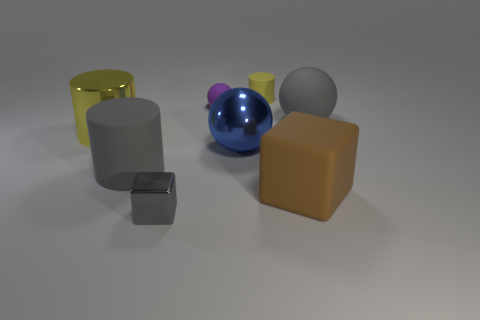What shape is the small object that is the same color as the large shiny cylinder?
Provide a short and direct response. Cylinder. What number of other objects are there of the same size as the blue sphere?
Keep it short and to the point. 4. Does the metallic cylinder have the same color as the small cylinder?
Offer a very short reply. Yes. Are there any other things that have the same color as the tiny metal thing?
Keep it short and to the point. Yes. How many blue things are spheres or small matte objects?
Give a very brief answer. 1. What is the object behind the purple object made of?
Give a very brief answer. Rubber. Is the number of yellow cylinders greater than the number of large red rubber cylinders?
Ensure brevity in your answer.  Yes. Does the gray matte object to the left of the big gray ball have the same shape as the tiny purple rubber object?
Your response must be concise. No. How many rubber objects are both to the left of the big gray sphere and right of the small shiny thing?
Provide a short and direct response. 3. What number of matte things are the same shape as the small gray metallic thing?
Offer a very short reply. 1. 